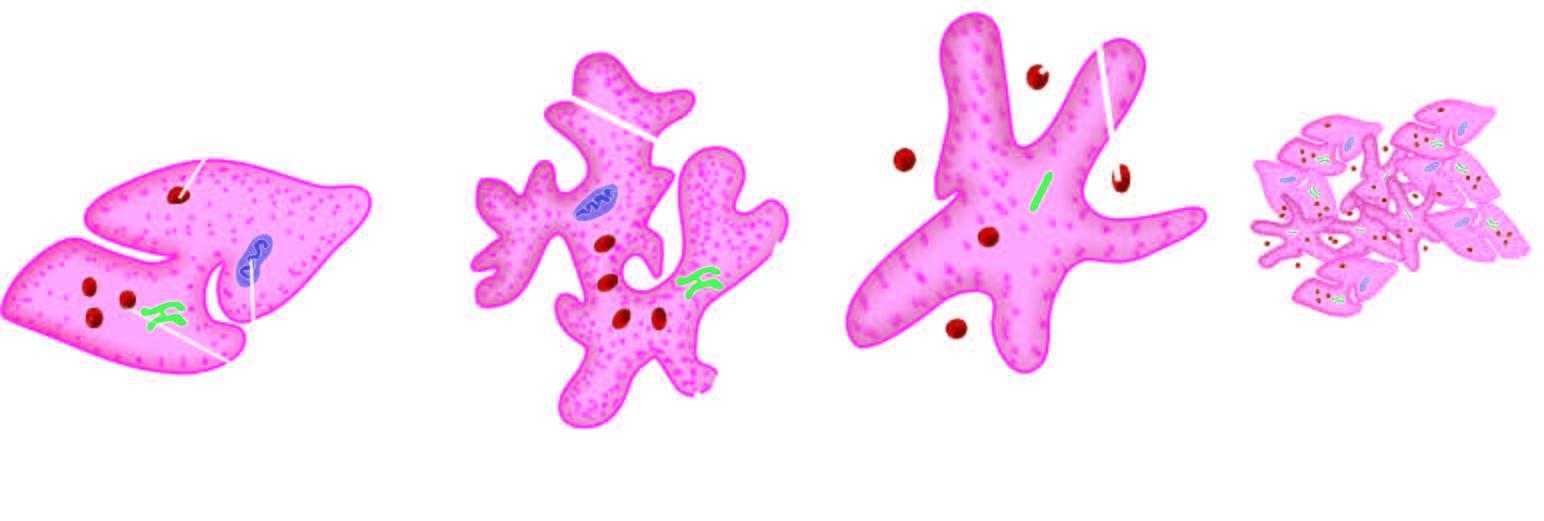s the alveolar spaces as well as interstitium dispersed in the cell?
Answer the question using a single word or phrase. No 